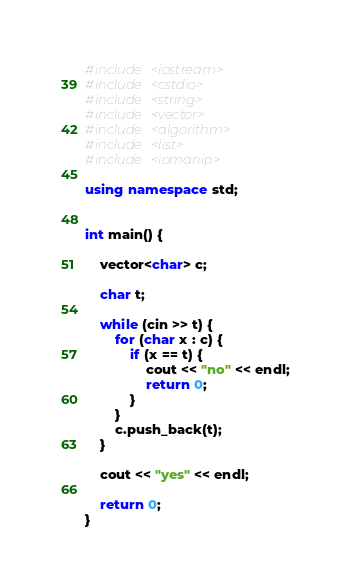<code> <loc_0><loc_0><loc_500><loc_500><_C++_>#include <iostream>
#include <cstdio>
#include <string>
#include <vector>
#include <algorithm>
#include <list>
#include <iomanip>

using namespace std;


int main() {

	vector<char> c;

	char t;

	while (cin >> t) {
		for (char x : c) {
			if (x == t) {
				cout << "no" << endl;
				return 0;
			}
		}
		c.push_back(t);
	}
	
	cout << "yes" << endl;
	
	return 0;
}
</code> 